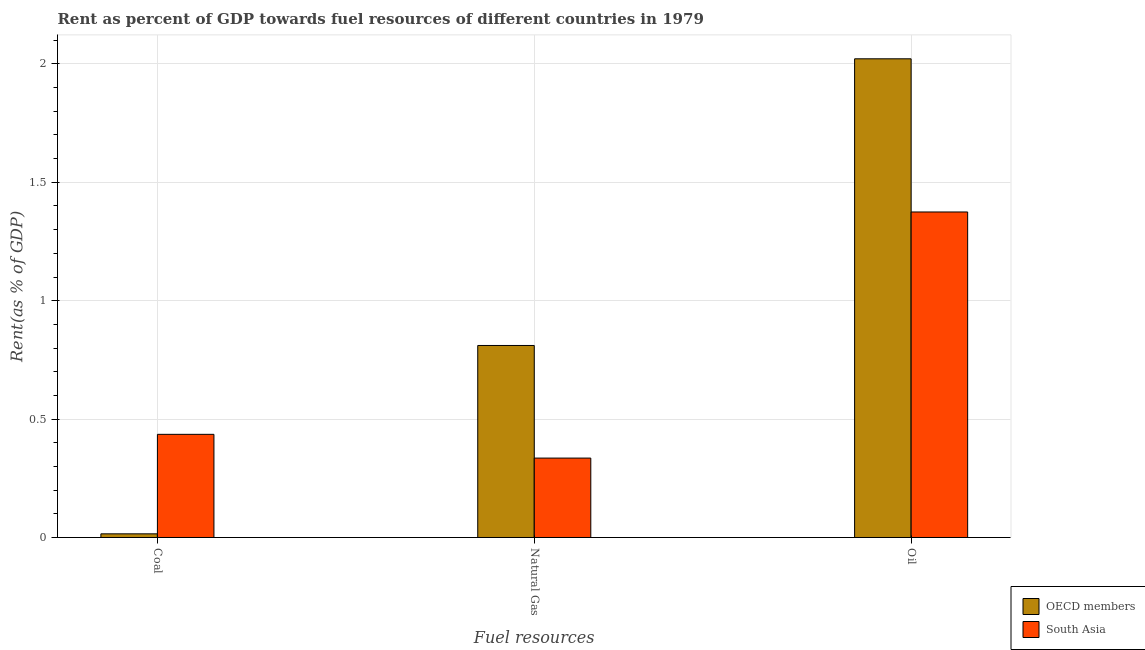How many different coloured bars are there?
Your answer should be compact. 2. Are the number of bars on each tick of the X-axis equal?
Give a very brief answer. Yes. How many bars are there on the 1st tick from the right?
Your answer should be very brief. 2. What is the label of the 3rd group of bars from the left?
Offer a very short reply. Oil. What is the rent towards natural gas in OECD members?
Keep it short and to the point. 0.81. Across all countries, what is the maximum rent towards natural gas?
Keep it short and to the point. 0.81. Across all countries, what is the minimum rent towards oil?
Ensure brevity in your answer.  1.37. In which country was the rent towards coal minimum?
Ensure brevity in your answer.  OECD members. What is the total rent towards natural gas in the graph?
Give a very brief answer. 1.15. What is the difference between the rent towards natural gas in OECD members and that in South Asia?
Keep it short and to the point. 0.48. What is the difference between the rent towards coal in OECD members and the rent towards oil in South Asia?
Ensure brevity in your answer.  -1.36. What is the average rent towards oil per country?
Make the answer very short. 1.7. What is the difference between the rent towards coal and rent towards oil in South Asia?
Provide a succinct answer. -0.94. What is the ratio of the rent towards oil in South Asia to that in OECD members?
Provide a succinct answer. 0.68. Is the rent towards natural gas in OECD members less than that in South Asia?
Keep it short and to the point. No. What is the difference between the highest and the second highest rent towards natural gas?
Your answer should be compact. 0.48. What is the difference between the highest and the lowest rent towards coal?
Ensure brevity in your answer.  0.42. Is the sum of the rent towards coal in OECD members and South Asia greater than the maximum rent towards oil across all countries?
Offer a terse response. No. What does the 1st bar from the right in Oil represents?
Your answer should be very brief. South Asia. Are the values on the major ticks of Y-axis written in scientific E-notation?
Your response must be concise. No. Does the graph contain any zero values?
Give a very brief answer. No. Does the graph contain grids?
Your answer should be very brief. Yes. Where does the legend appear in the graph?
Keep it short and to the point. Bottom right. How many legend labels are there?
Keep it short and to the point. 2. What is the title of the graph?
Provide a succinct answer. Rent as percent of GDP towards fuel resources of different countries in 1979. Does "Djibouti" appear as one of the legend labels in the graph?
Offer a terse response. No. What is the label or title of the X-axis?
Keep it short and to the point. Fuel resources. What is the label or title of the Y-axis?
Your response must be concise. Rent(as % of GDP). What is the Rent(as % of GDP) in OECD members in Coal?
Provide a succinct answer. 0.02. What is the Rent(as % of GDP) of South Asia in Coal?
Keep it short and to the point. 0.44. What is the Rent(as % of GDP) in OECD members in Natural Gas?
Provide a succinct answer. 0.81. What is the Rent(as % of GDP) in South Asia in Natural Gas?
Your answer should be very brief. 0.34. What is the Rent(as % of GDP) in OECD members in Oil?
Offer a very short reply. 2.02. What is the Rent(as % of GDP) of South Asia in Oil?
Make the answer very short. 1.37. Across all Fuel resources, what is the maximum Rent(as % of GDP) in OECD members?
Give a very brief answer. 2.02. Across all Fuel resources, what is the maximum Rent(as % of GDP) in South Asia?
Offer a terse response. 1.37. Across all Fuel resources, what is the minimum Rent(as % of GDP) of OECD members?
Ensure brevity in your answer.  0.02. Across all Fuel resources, what is the minimum Rent(as % of GDP) in South Asia?
Keep it short and to the point. 0.34. What is the total Rent(as % of GDP) of OECD members in the graph?
Make the answer very short. 2.85. What is the total Rent(as % of GDP) of South Asia in the graph?
Your answer should be very brief. 2.15. What is the difference between the Rent(as % of GDP) in OECD members in Coal and that in Natural Gas?
Keep it short and to the point. -0.8. What is the difference between the Rent(as % of GDP) in South Asia in Coal and that in Natural Gas?
Offer a very short reply. 0.1. What is the difference between the Rent(as % of GDP) in OECD members in Coal and that in Oil?
Provide a short and direct response. -2.01. What is the difference between the Rent(as % of GDP) of South Asia in Coal and that in Oil?
Your response must be concise. -0.94. What is the difference between the Rent(as % of GDP) in OECD members in Natural Gas and that in Oil?
Provide a succinct answer. -1.21. What is the difference between the Rent(as % of GDP) in South Asia in Natural Gas and that in Oil?
Provide a succinct answer. -1.04. What is the difference between the Rent(as % of GDP) of OECD members in Coal and the Rent(as % of GDP) of South Asia in Natural Gas?
Your response must be concise. -0.32. What is the difference between the Rent(as % of GDP) of OECD members in Coal and the Rent(as % of GDP) of South Asia in Oil?
Ensure brevity in your answer.  -1.36. What is the difference between the Rent(as % of GDP) in OECD members in Natural Gas and the Rent(as % of GDP) in South Asia in Oil?
Ensure brevity in your answer.  -0.56. What is the average Rent(as % of GDP) in OECD members per Fuel resources?
Ensure brevity in your answer.  0.95. What is the average Rent(as % of GDP) in South Asia per Fuel resources?
Offer a terse response. 0.72. What is the difference between the Rent(as % of GDP) in OECD members and Rent(as % of GDP) in South Asia in Coal?
Offer a very short reply. -0.42. What is the difference between the Rent(as % of GDP) in OECD members and Rent(as % of GDP) in South Asia in Natural Gas?
Offer a very short reply. 0.48. What is the difference between the Rent(as % of GDP) of OECD members and Rent(as % of GDP) of South Asia in Oil?
Make the answer very short. 0.65. What is the ratio of the Rent(as % of GDP) of OECD members in Coal to that in Natural Gas?
Keep it short and to the point. 0.02. What is the ratio of the Rent(as % of GDP) in South Asia in Coal to that in Natural Gas?
Your answer should be very brief. 1.3. What is the ratio of the Rent(as % of GDP) of OECD members in Coal to that in Oil?
Provide a succinct answer. 0.01. What is the ratio of the Rent(as % of GDP) in South Asia in Coal to that in Oil?
Offer a very short reply. 0.32. What is the ratio of the Rent(as % of GDP) in OECD members in Natural Gas to that in Oil?
Give a very brief answer. 0.4. What is the ratio of the Rent(as % of GDP) of South Asia in Natural Gas to that in Oil?
Your response must be concise. 0.24. What is the difference between the highest and the second highest Rent(as % of GDP) of OECD members?
Offer a very short reply. 1.21. What is the difference between the highest and the second highest Rent(as % of GDP) of South Asia?
Offer a terse response. 0.94. What is the difference between the highest and the lowest Rent(as % of GDP) of OECD members?
Provide a succinct answer. 2.01. What is the difference between the highest and the lowest Rent(as % of GDP) of South Asia?
Your answer should be very brief. 1.04. 